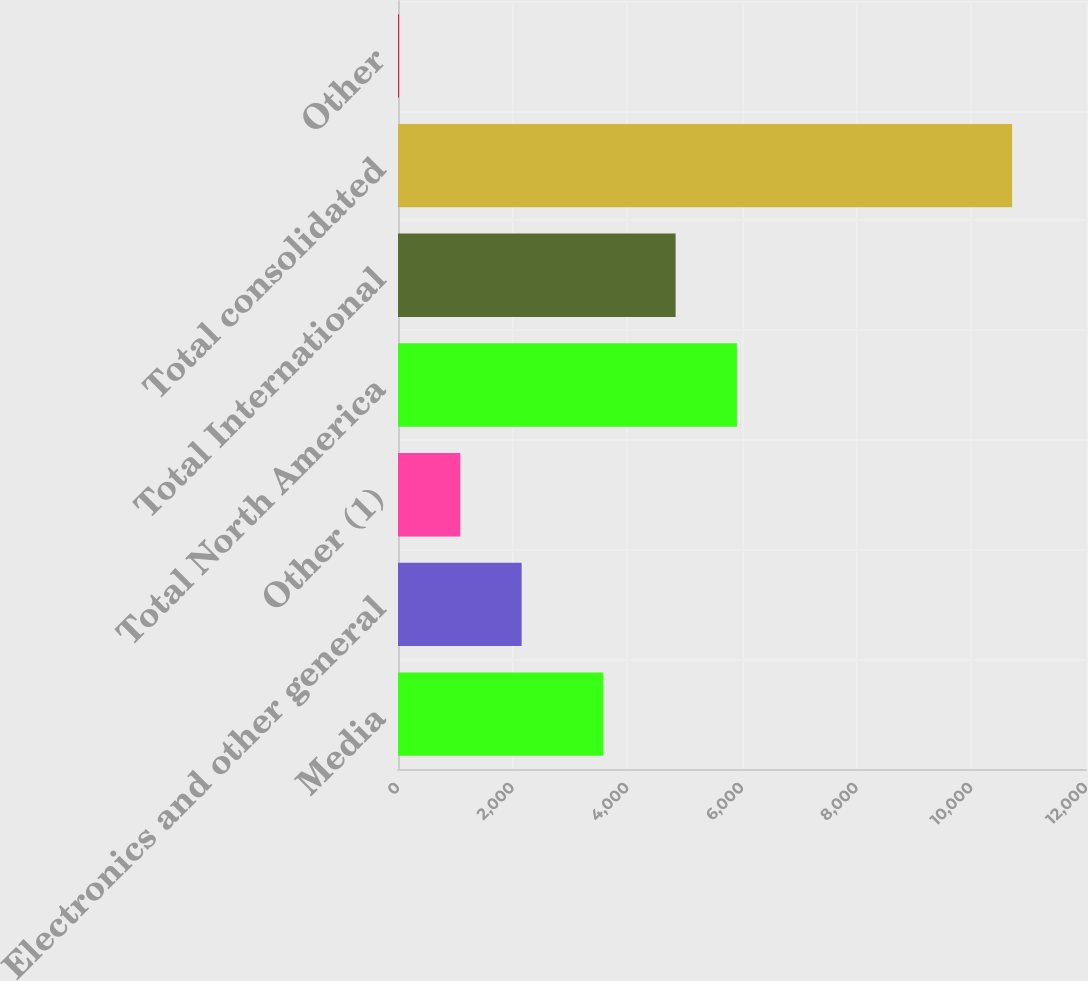Convert chart. <chart><loc_0><loc_0><loc_500><loc_500><bar_chart><fcel>Media<fcel>Electronics and other general<fcel>Other (1)<fcel>Total North America<fcel>Total International<fcel>Total consolidated<fcel>Other<nl><fcel>3582<fcel>2156.6<fcel>1087.3<fcel>5911.3<fcel>4842<fcel>10711<fcel>18<nl></chart> 